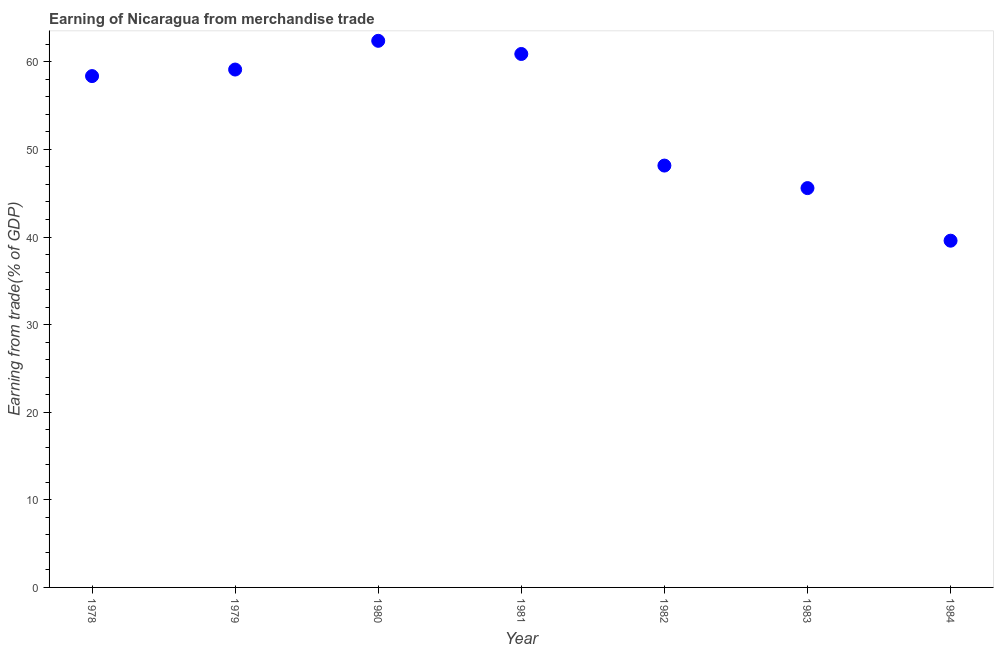What is the earning from merchandise trade in 1979?
Provide a short and direct response. 59.12. Across all years, what is the maximum earning from merchandise trade?
Your response must be concise. 62.4. Across all years, what is the minimum earning from merchandise trade?
Keep it short and to the point. 39.58. In which year was the earning from merchandise trade minimum?
Ensure brevity in your answer.  1984. What is the sum of the earning from merchandise trade?
Your answer should be very brief. 374.11. What is the difference between the earning from merchandise trade in 1982 and 1984?
Ensure brevity in your answer.  8.57. What is the average earning from merchandise trade per year?
Provide a short and direct response. 53.44. What is the median earning from merchandise trade?
Your answer should be very brief. 58.37. What is the ratio of the earning from merchandise trade in 1978 to that in 1982?
Give a very brief answer. 1.21. Is the earning from merchandise trade in 1978 less than that in 1983?
Keep it short and to the point. No. What is the difference between the highest and the second highest earning from merchandise trade?
Your response must be concise. 1.5. What is the difference between the highest and the lowest earning from merchandise trade?
Offer a very short reply. 22.82. In how many years, is the earning from merchandise trade greater than the average earning from merchandise trade taken over all years?
Provide a succinct answer. 4. How many dotlines are there?
Your response must be concise. 1. How many years are there in the graph?
Ensure brevity in your answer.  7. What is the difference between two consecutive major ticks on the Y-axis?
Offer a very short reply. 10. Does the graph contain any zero values?
Your answer should be very brief. No. What is the title of the graph?
Give a very brief answer. Earning of Nicaragua from merchandise trade. What is the label or title of the Y-axis?
Provide a short and direct response. Earning from trade(% of GDP). What is the Earning from trade(% of GDP) in 1978?
Provide a short and direct response. 58.37. What is the Earning from trade(% of GDP) in 1979?
Offer a very short reply. 59.12. What is the Earning from trade(% of GDP) in 1980?
Offer a very short reply. 62.4. What is the Earning from trade(% of GDP) in 1981?
Offer a very short reply. 60.9. What is the Earning from trade(% of GDP) in 1982?
Offer a terse response. 48.16. What is the Earning from trade(% of GDP) in 1983?
Make the answer very short. 45.58. What is the Earning from trade(% of GDP) in 1984?
Offer a terse response. 39.58. What is the difference between the Earning from trade(% of GDP) in 1978 and 1979?
Give a very brief answer. -0.75. What is the difference between the Earning from trade(% of GDP) in 1978 and 1980?
Your response must be concise. -4.03. What is the difference between the Earning from trade(% of GDP) in 1978 and 1981?
Your answer should be compact. -2.52. What is the difference between the Earning from trade(% of GDP) in 1978 and 1982?
Your answer should be very brief. 10.22. What is the difference between the Earning from trade(% of GDP) in 1978 and 1983?
Offer a terse response. 12.79. What is the difference between the Earning from trade(% of GDP) in 1978 and 1984?
Give a very brief answer. 18.79. What is the difference between the Earning from trade(% of GDP) in 1979 and 1980?
Offer a very short reply. -3.28. What is the difference between the Earning from trade(% of GDP) in 1979 and 1981?
Provide a short and direct response. -1.78. What is the difference between the Earning from trade(% of GDP) in 1979 and 1982?
Give a very brief answer. 10.96. What is the difference between the Earning from trade(% of GDP) in 1979 and 1983?
Keep it short and to the point. 13.53. What is the difference between the Earning from trade(% of GDP) in 1979 and 1984?
Your answer should be very brief. 19.54. What is the difference between the Earning from trade(% of GDP) in 1980 and 1981?
Offer a very short reply. 1.5. What is the difference between the Earning from trade(% of GDP) in 1980 and 1982?
Provide a succinct answer. 14.24. What is the difference between the Earning from trade(% of GDP) in 1980 and 1983?
Offer a very short reply. 16.81. What is the difference between the Earning from trade(% of GDP) in 1980 and 1984?
Keep it short and to the point. 22.82. What is the difference between the Earning from trade(% of GDP) in 1981 and 1982?
Provide a succinct answer. 12.74. What is the difference between the Earning from trade(% of GDP) in 1981 and 1983?
Ensure brevity in your answer.  15.31. What is the difference between the Earning from trade(% of GDP) in 1981 and 1984?
Provide a succinct answer. 21.31. What is the difference between the Earning from trade(% of GDP) in 1982 and 1983?
Ensure brevity in your answer.  2.57. What is the difference between the Earning from trade(% of GDP) in 1982 and 1984?
Your answer should be very brief. 8.57. What is the difference between the Earning from trade(% of GDP) in 1983 and 1984?
Your answer should be very brief. 6. What is the ratio of the Earning from trade(% of GDP) in 1978 to that in 1979?
Your answer should be compact. 0.99. What is the ratio of the Earning from trade(% of GDP) in 1978 to that in 1980?
Offer a very short reply. 0.94. What is the ratio of the Earning from trade(% of GDP) in 1978 to that in 1981?
Your answer should be very brief. 0.96. What is the ratio of the Earning from trade(% of GDP) in 1978 to that in 1982?
Provide a short and direct response. 1.21. What is the ratio of the Earning from trade(% of GDP) in 1978 to that in 1983?
Give a very brief answer. 1.28. What is the ratio of the Earning from trade(% of GDP) in 1978 to that in 1984?
Offer a very short reply. 1.48. What is the ratio of the Earning from trade(% of GDP) in 1979 to that in 1980?
Give a very brief answer. 0.95. What is the ratio of the Earning from trade(% of GDP) in 1979 to that in 1981?
Your answer should be compact. 0.97. What is the ratio of the Earning from trade(% of GDP) in 1979 to that in 1982?
Your response must be concise. 1.23. What is the ratio of the Earning from trade(% of GDP) in 1979 to that in 1983?
Make the answer very short. 1.3. What is the ratio of the Earning from trade(% of GDP) in 1979 to that in 1984?
Provide a succinct answer. 1.49. What is the ratio of the Earning from trade(% of GDP) in 1980 to that in 1982?
Offer a terse response. 1.3. What is the ratio of the Earning from trade(% of GDP) in 1980 to that in 1983?
Ensure brevity in your answer.  1.37. What is the ratio of the Earning from trade(% of GDP) in 1980 to that in 1984?
Your answer should be very brief. 1.58. What is the ratio of the Earning from trade(% of GDP) in 1981 to that in 1982?
Keep it short and to the point. 1.26. What is the ratio of the Earning from trade(% of GDP) in 1981 to that in 1983?
Your answer should be compact. 1.34. What is the ratio of the Earning from trade(% of GDP) in 1981 to that in 1984?
Ensure brevity in your answer.  1.54. What is the ratio of the Earning from trade(% of GDP) in 1982 to that in 1983?
Your answer should be very brief. 1.06. What is the ratio of the Earning from trade(% of GDP) in 1982 to that in 1984?
Provide a succinct answer. 1.22. What is the ratio of the Earning from trade(% of GDP) in 1983 to that in 1984?
Keep it short and to the point. 1.15. 